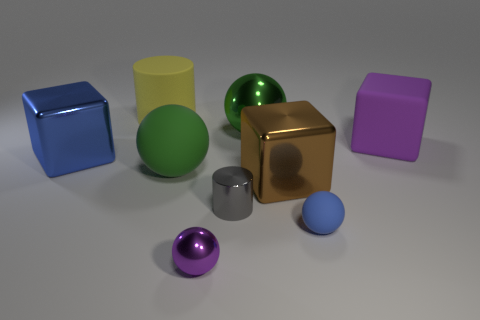Subtract 2 balls. How many balls are left? 2 Add 1 large brown metal objects. How many objects exist? 10 Subtract all blocks. How many objects are left? 6 Add 2 purple metallic things. How many purple metallic things are left? 3 Add 2 large brown metal things. How many large brown metal things exist? 3 Subtract 1 blue balls. How many objects are left? 8 Subtract all small gray rubber cubes. Subtract all large purple matte cubes. How many objects are left? 8 